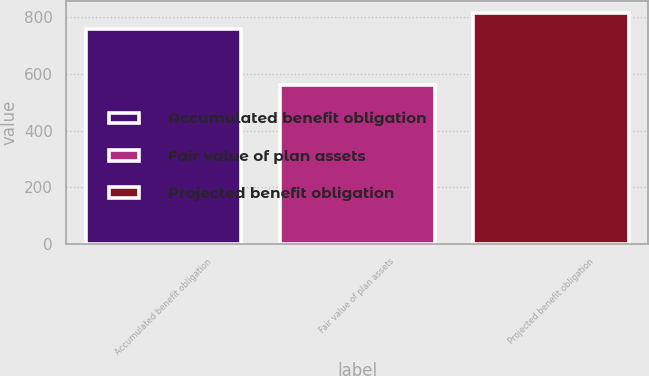<chart> <loc_0><loc_0><loc_500><loc_500><bar_chart><fcel>Accumulated benefit obligation<fcel>Fair value of plan assets<fcel>Projected benefit obligation<nl><fcel>759<fcel>562<fcel>816<nl></chart> 